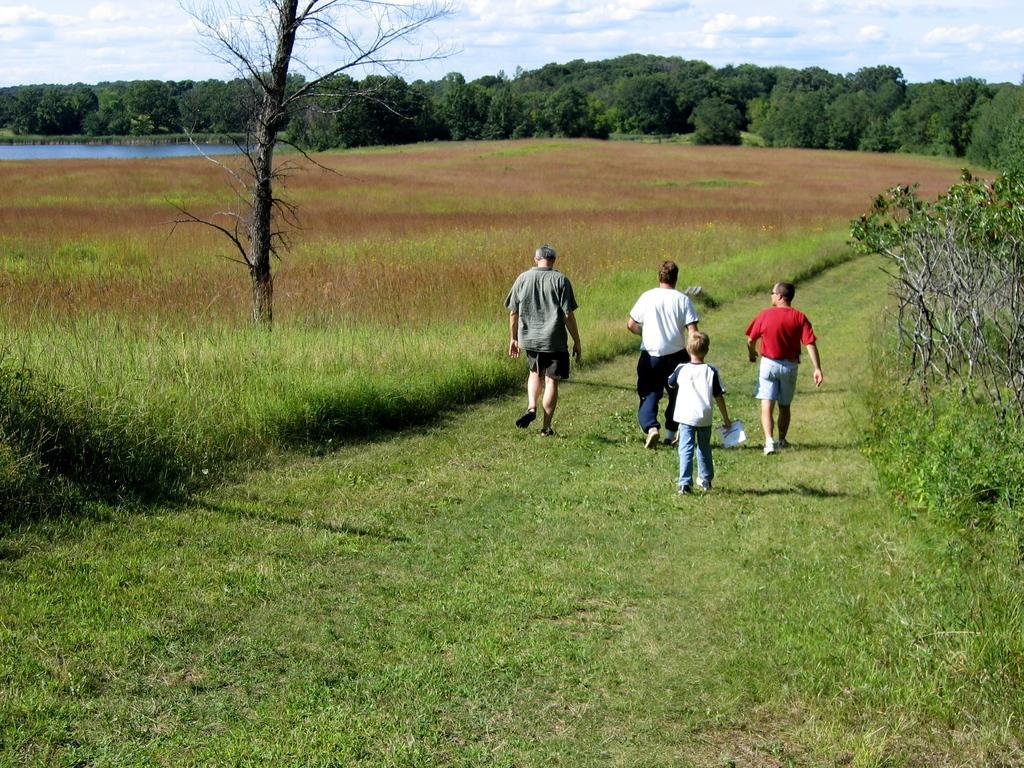Could you give a brief overview of what you see in this image? In this image we can see some persons, trees, plants, grass and other objects. In the background of the image there are trees, water and ground. At the top of the image there is the sky. At the bottom of the image there is the grass. 